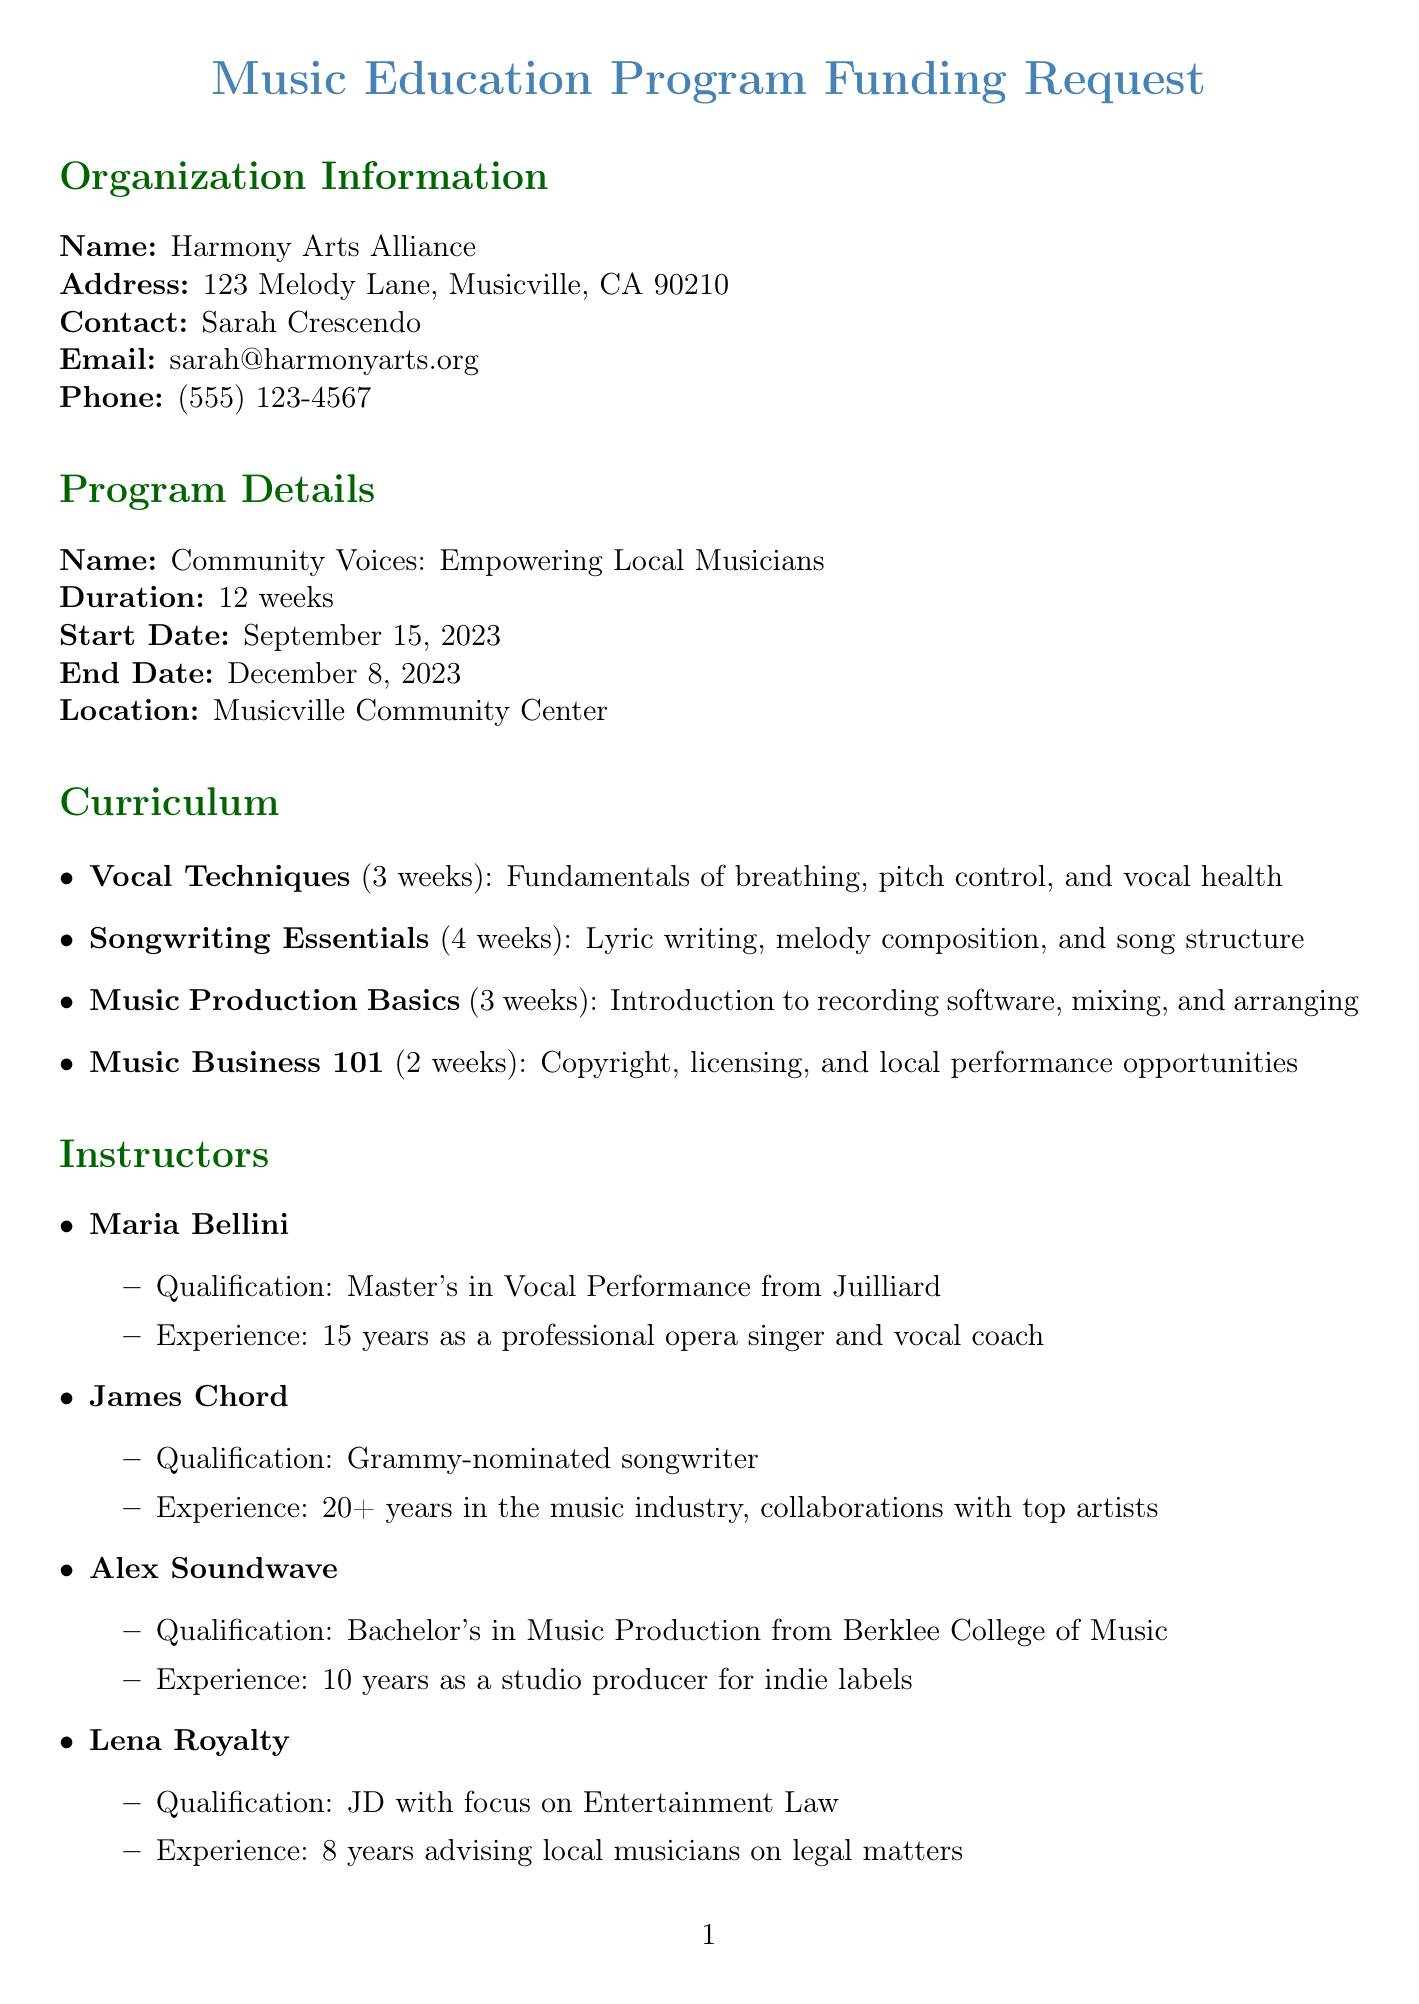What is the name of the program? The program name is specified in the program details section of the document.
Answer: Community Voices: Empowering Local Musicians What is the duration of the program? The duration of the program is highlighted in the program details section.
Answer: 12 weeks Who is the contact person for this organization? The contact person's name is included in the organization information section.
Answer: Sarah Crescendo What is the start date of the program? The start date is mentioned in the program details section of the document.
Answer: September 15, 2023 How many modules are in the curriculum? Counting the listed modules in the curriculum section gives this information.
Answer: 4 What is the total requested amount for funding? The total amount is noted in the budget request section.
Answer: 26,500 Which demographic is targeted for participation? The target demographic is defined in the community impact section of the document.
Answer: Aspiring musicians aged 16-30 from underserved communities What is one expected outcome of the program? Expected outcomes are listed, and this question asks for any one of them.
Answer: Participants will develop foundational skills in singing, songwriting, and music production Who teaches the "Music Business 101" module? The curriculum section lists instructors associated with each module.
Answer: Lena Royalty What partnership opportunity is mentioned? The community impact section includes partnership opportunities.
Answer: Local music stores for equipment discounts 